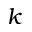<formula> <loc_0><loc_0><loc_500><loc_500>k</formula> 